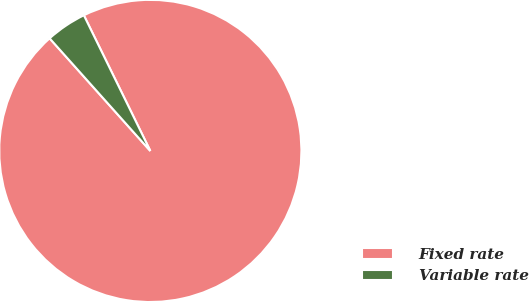Convert chart. <chart><loc_0><loc_0><loc_500><loc_500><pie_chart><fcel>Fixed rate<fcel>Variable rate<nl><fcel>95.64%<fcel>4.36%<nl></chart> 